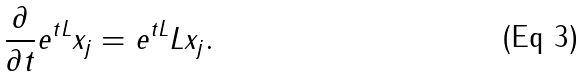Convert formula to latex. <formula><loc_0><loc_0><loc_500><loc_500>\frac { \partial } { \partial { t } } e ^ { t L } x _ { j } = e ^ { t L } L x _ { j } .</formula> 